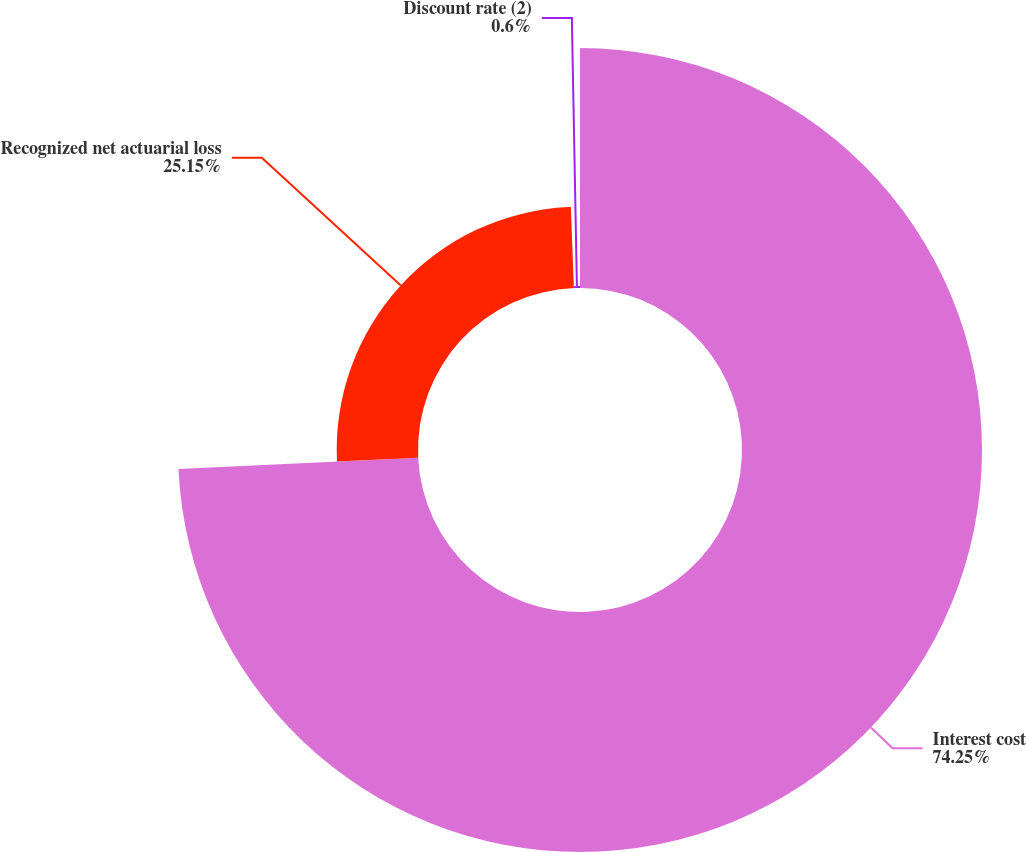<chart> <loc_0><loc_0><loc_500><loc_500><pie_chart><fcel>Interest cost<fcel>Recognized net actuarial loss<fcel>Discount rate (2)<nl><fcel>74.24%<fcel>25.15%<fcel>0.6%<nl></chart> 